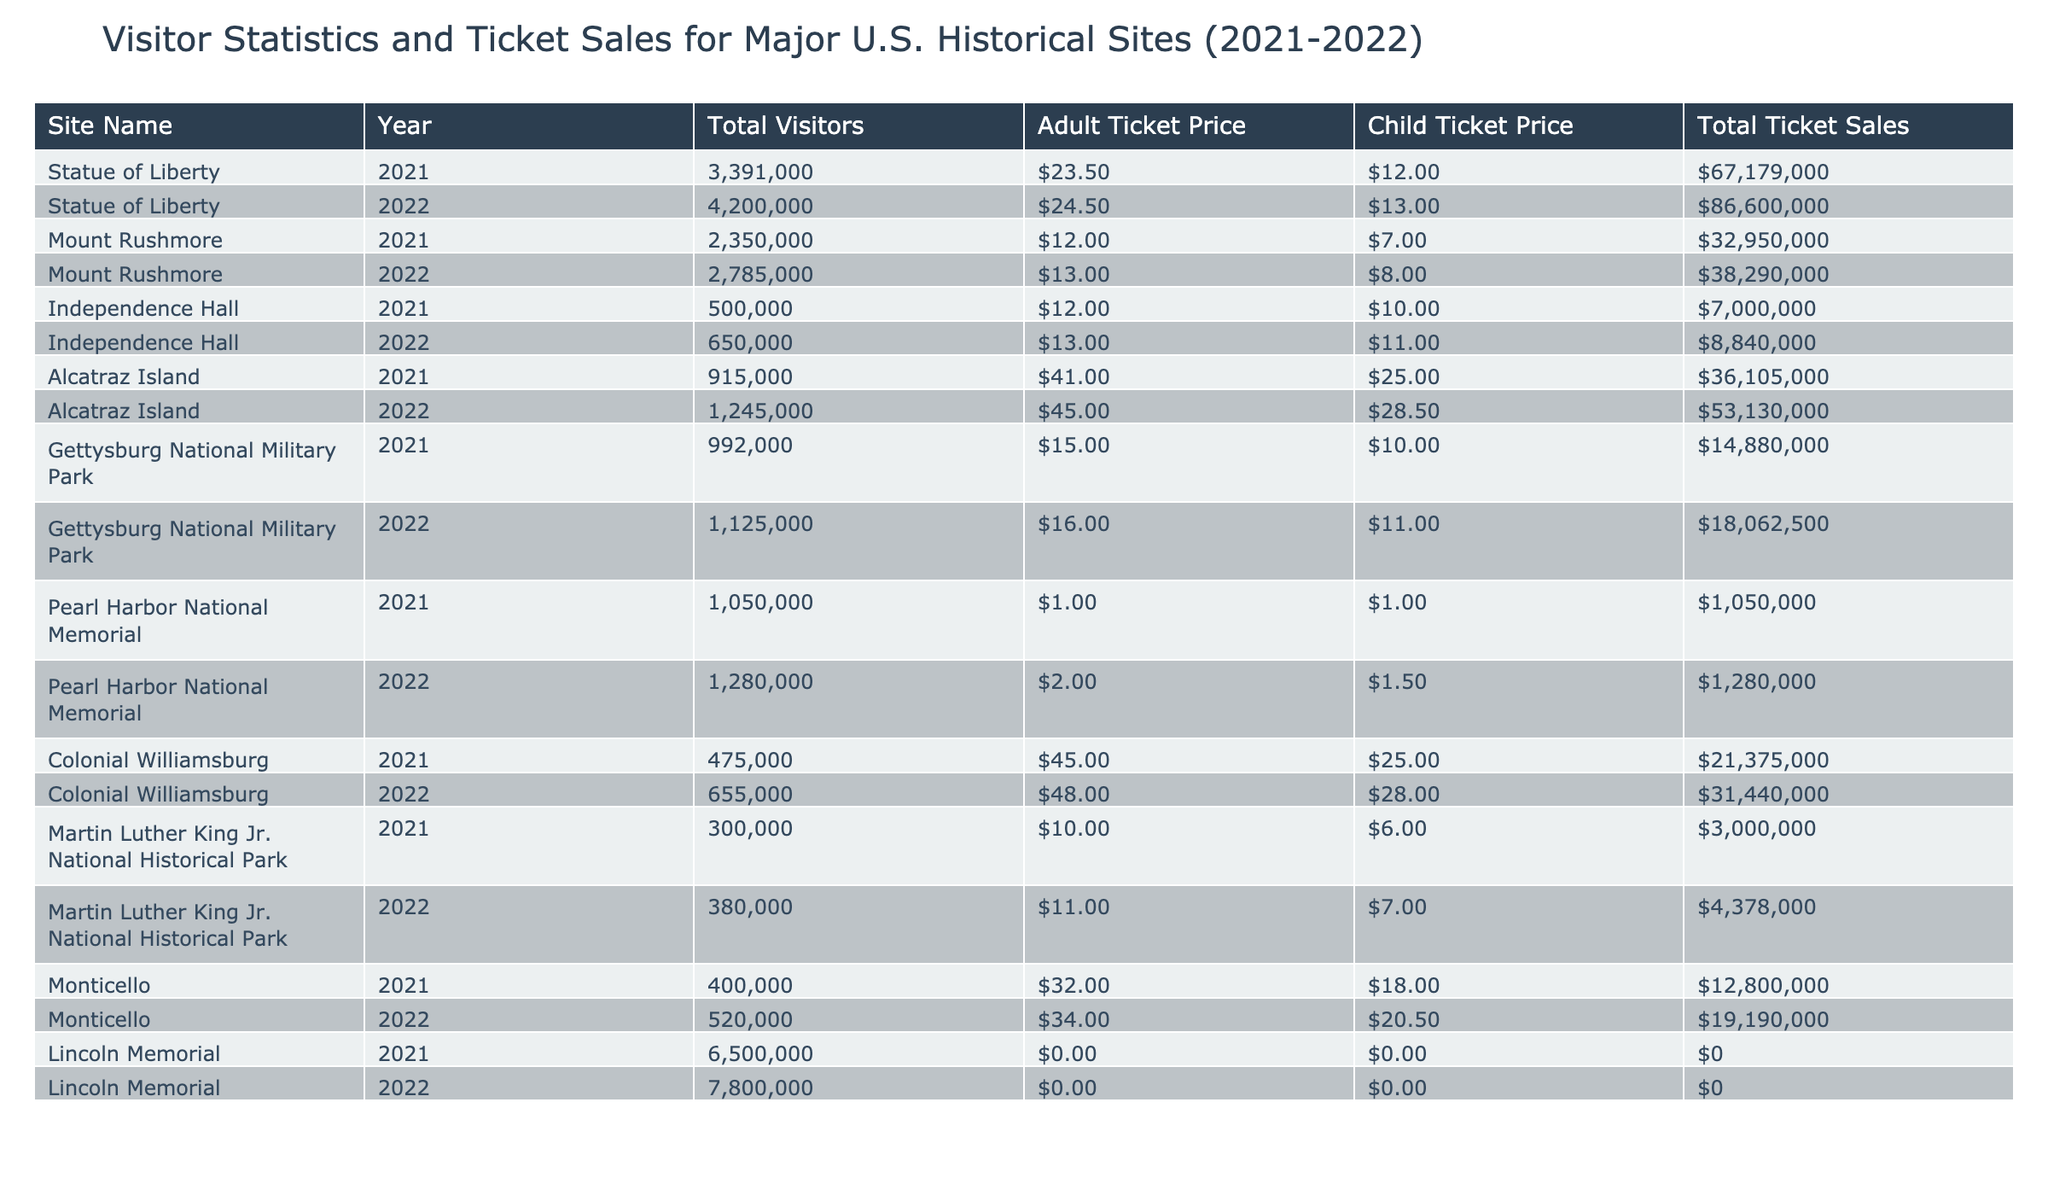What was the total ticket sales for the Statue of Liberty in 2022? The table shows the total ticket sales for the Statue of Liberty in 2022. It directly provides the value: 86,600,000.
Answer: 86,600,000 How many total visitors did Mount Rushmore have in 2021 and 2022 combined? To find the combined total visitors for Mount Rushmore, add the visitors from both years: 2,350,000 (2021) + 2,785,000 (2022) = 5,135,000.
Answer: 5,135,000 What was the child ticket price for Independence Hall in 2021? The table states the child ticket price for Independence Hall in 2021 is 10.00.
Answer: 10.00 Did the total ticket sales for Pearl Harbor National Memorial increase from 2021 to 2022? The total ticket sales for Pearl Harbor National Memorial in 2021 were 1,050,000, and in 2022, it was 1,280,000. Since 1,280,000 is greater than 1,050,000, the total sales did increase.
Answer: Yes What was the percentage increase in total visitors for Alcatraz Island from 2021 to 2022? To calculate the percentage increase, first determine the difference in total visitors: 1,245,000 (2022) - 915,000 (2021) = 330,000. Then divide that by the 2021 visitors and multiply by 100: (330,000 / 915,000) * 100 ≈ 36.1%.
Answer: Approximately 36.1% Which historical site had the highest adult ticket price in 2022? By examining the adult ticket prices for all sites in 2022, Alcatraz Island had the highest adult ticket price at 45.00.
Answer: Alcatraz Island What is the average total ticket sales across all sites in 2022? To find the average, sum up all the total ticket sales for 2022 (86,600,000 + 38,290,000 + 8,840,000 + 53,130,000 + 18,062,500 + 1,280,000 + 31,440,000 + 4,378,000 + 19,190,000 + 0) = 266,310,500. Then divide by the number of sites (10): 266,310,500 / 10 = 26,631,050.
Answer: 26,631,050 Was the total ticket sales from Lincoln Memorial non-existent in both years? The table shows that the total ticket sales for Lincoln Memorial in 2021 and 2022 are both listed as 0. Therefore, the total ticket sales were indeed non-existent.
Answer: Yes What was the total visitor count for Gettysburg National Military Park in 2022 compared to Independence Hall in the same year? The total visitors for Gettysburg in 2022 were 1,125,000, while Independence Hall had 650,000. Comparing these values shows that Gettysburg had more visitors.
Answer: Gettysburg had more visitors 